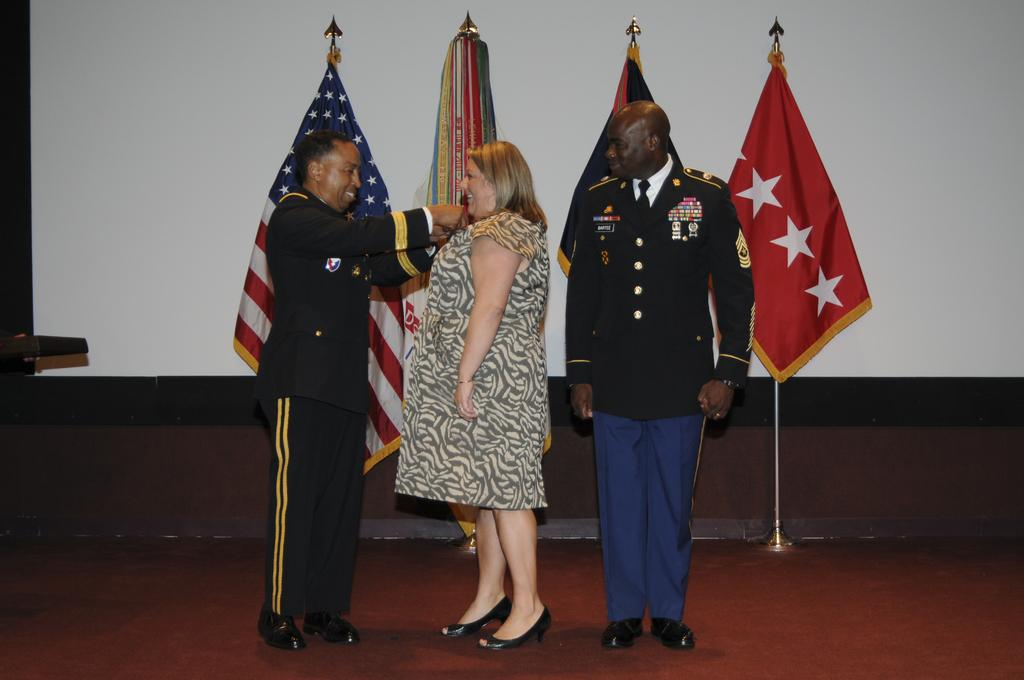How many people are in the image? There are persons in the image, but the exact number is not specified. What can be seen in the background of the image? There are flags with stands and a wall in the background of the image. Are there any other objects visible in the background? Yes, there are other objects in the background of the image. What is visible at the bottom of the image? The floor is visible at the bottom of the image. What type of icicle can be seen hanging from the wall in the image? There is no icicle present in the image; it is not a winter scene. Is there a hospital visible in the image? There is no mention of a hospital in the image or the provided facts. 